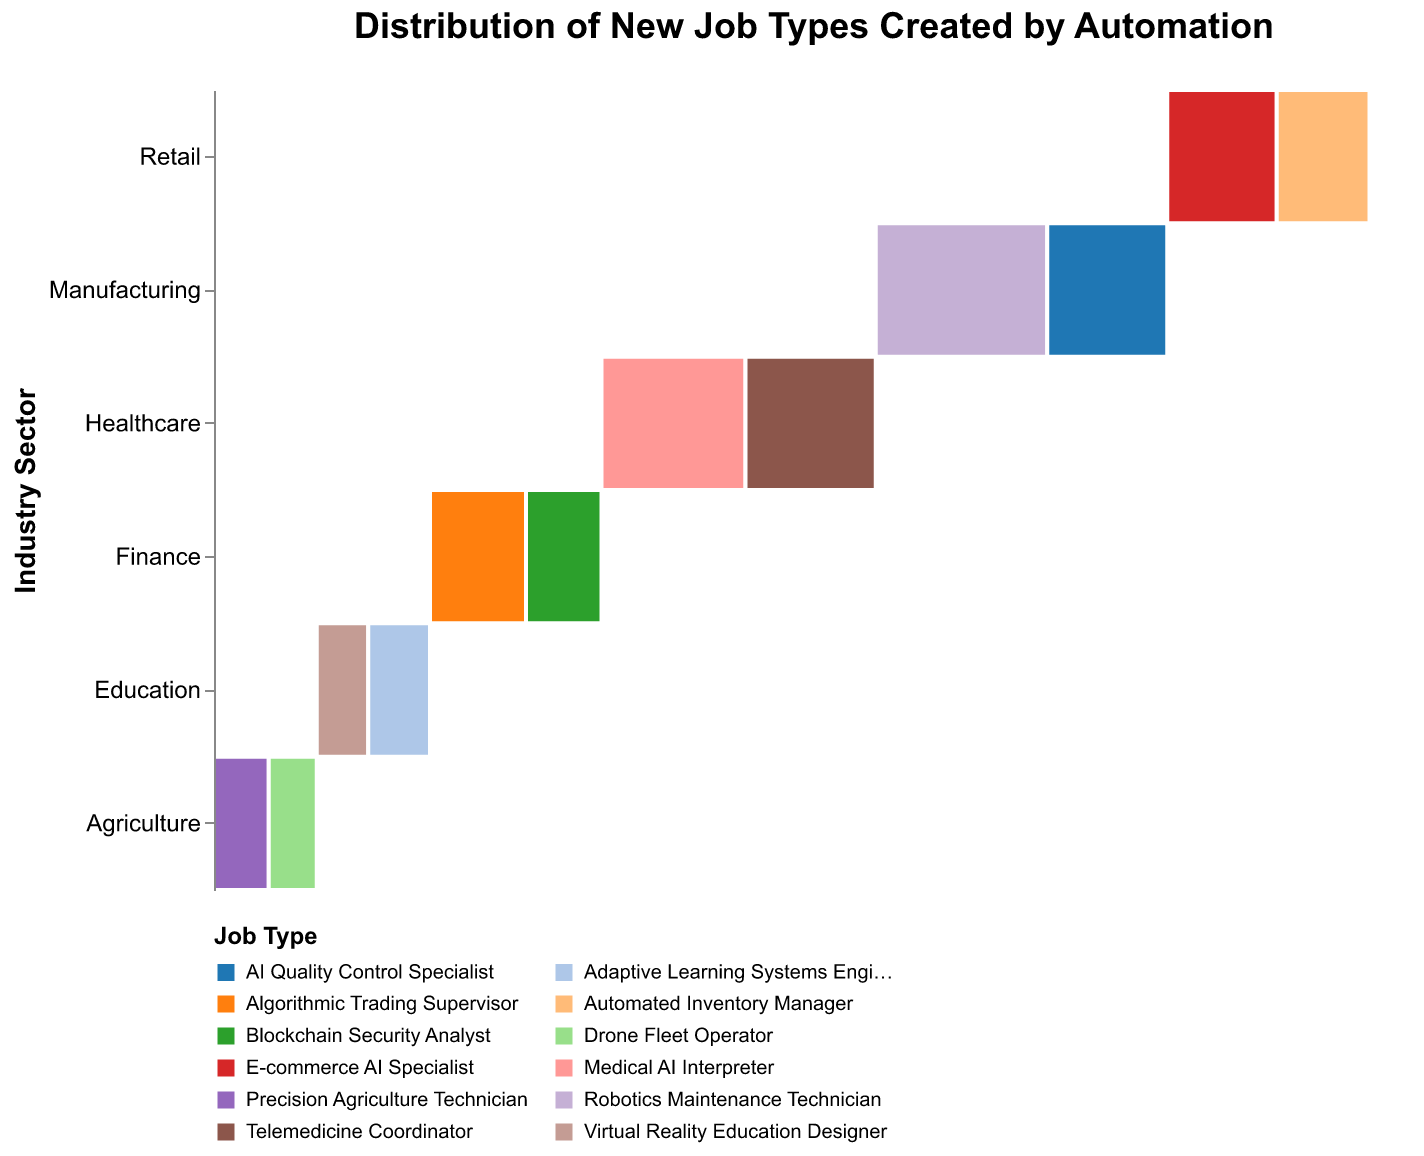What's the title of the figure? The title of the figure is displayed at the top and provides an overall description of what the plot is about.
Answer: Distribution of New Job Types Created by Automation In which industry sector do Robotics Maintenance Technicians have job distribution? Robotics Maintenance Technicians can be identified by their color in the Mosaic Plot, and their position shows they belong to the Manufacturing sector.
Answer: Manufacturing Which job type in the Healthcare sector has more jobs, Medical AI Interpreter or Telemedicine Coordinator? By comparing the widths of the colored areas for these two job types within the Healthcare sector, we can see which section is larger. Medical AI Interpreter has a wider section than Telemedicine Coordinator.
Answer: Medical AI Interpreter What's the total number of new job types in the Finance sector? Adding up the number of jobs for all job types within the Finance sector: Algorithmic Trading Supervisor (2800) + Blockchain Security Analyst (2200) = 5000.
Answer: 5000 Which sector has the highest variety of job types introduced by automation? By visually scanning the number of differently colored segments in each sector, we can see which has the most job types. Manufacturing and Healthcare each show two different job types.
Answer: Manufacturing and Healthcare What's the percentage of jobs for AI Quality Control Specialists in the Manufacturing sector? The tooltip in the plot might indicate this percentage, or we can calculate it (3500 jobs in AI Quality Control out of the total 37100 new jobs). Percentage = (3500 / 37100) x 100 ≈ 9.4%.
Answer: Roughly 9.4% How do job distributions in Agriculture compare to those in Retail? Compare the distribution widths for Precision Agriculture Technician and Drone Fleet Operator in Agriculture with E-commerce AI Specialist and Automated Inventory Manager in Retail. Retail has higher numbers showing larger segments.
Answer: Retail has a greater number of jobs Which job type is unique to the Education sector? By examining the color legend and the segments within the Education sector, we identify job types specific to this sector. Virtual Reality Education Designer and Adaptive Learning Systems Engineer are unique.
Answer: Virtual Reality Education Designer and Adaptive Learning Systems Engineer What's the main skill set required for the largest job type in Manufacturing? Identify the largest job type within the Manufacturing sector by the width of its segment, and then find its skill set from the plot or legend. Robotics Maintenance Technician has the largest number and requires Technical skills.
Answer: Technical Skills for Robotics Maintenance Technician 